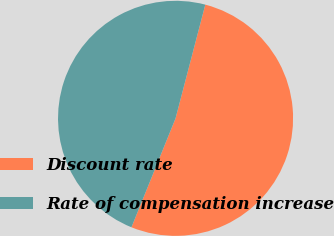<chart> <loc_0><loc_0><loc_500><loc_500><pie_chart><fcel>Discount rate<fcel>Rate of compensation increase<nl><fcel>52.05%<fcel>47.95%<nl></chart> 